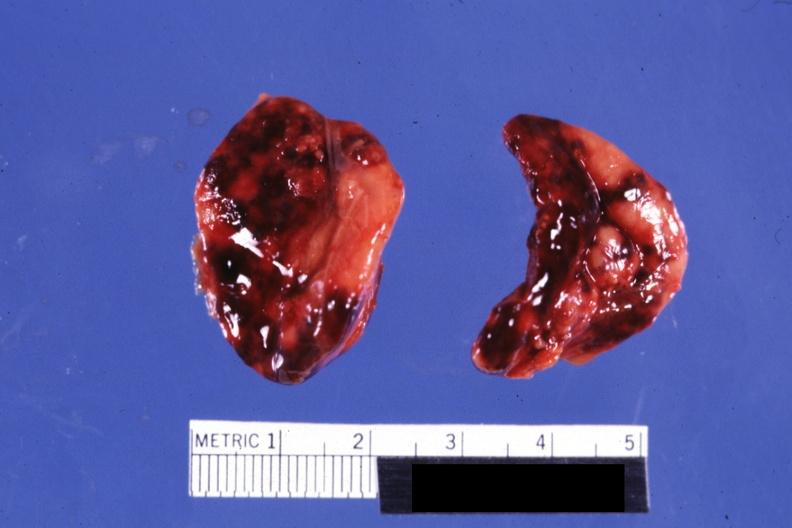what looks like placental abruption?
Answer the question using a single word or phrase. Both adrenals external views focal hemorrhages do not know history 